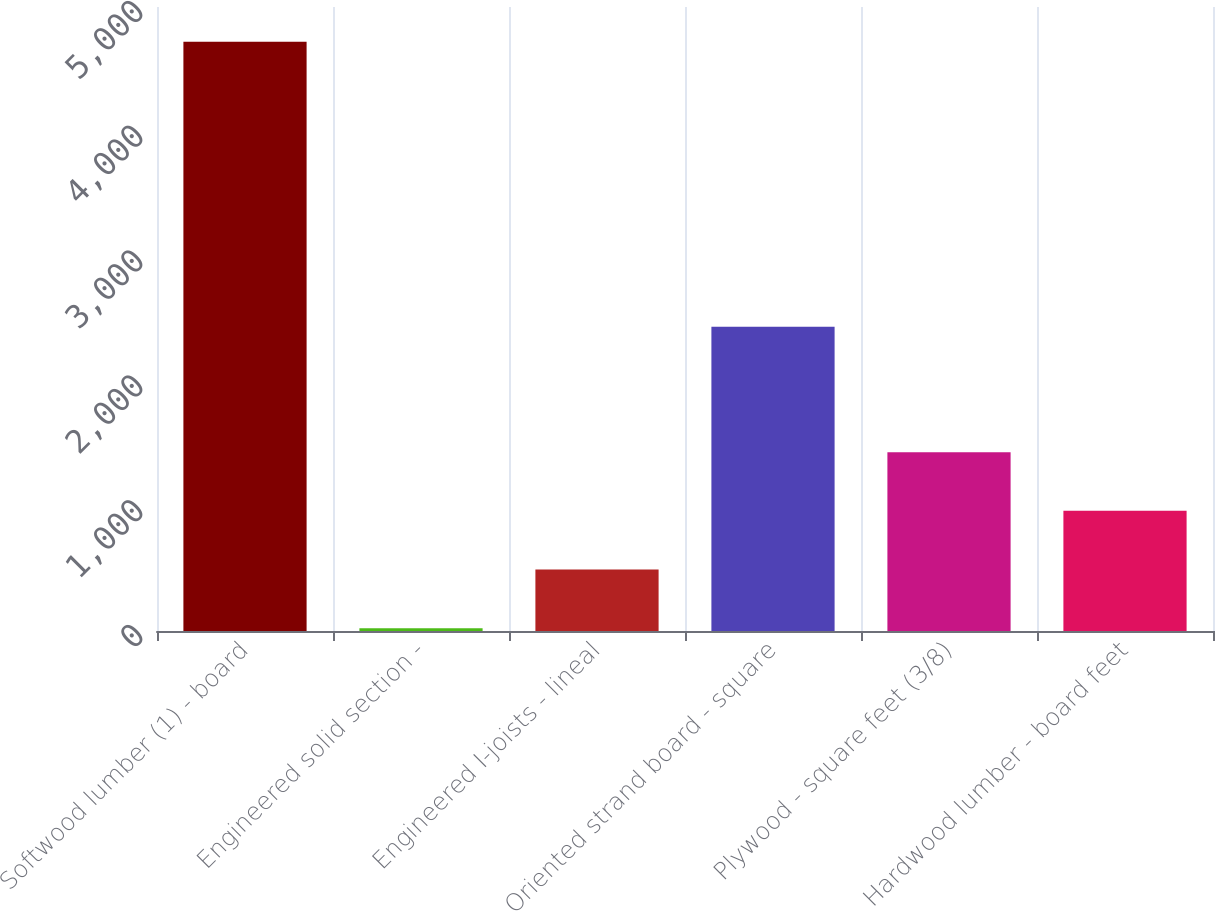Convert chart to OTSL. <chart><loc_0><loc_0><loc_500><loc_500><bar_chart><fcel>Softwood lumber (1) - board<fcel>Engineered solid section -<fcel>Engineered I-joists - lineal<fcel>Oriented strand board - square<fcel>Plywood - square feet (3/8)<fcel>Hardwood lumber - board feet<nl><fcel>4722<fcel>23<fcel>492.9<fcel>2438<fcel>1432.7<fcel>962.8<nl></chart> 